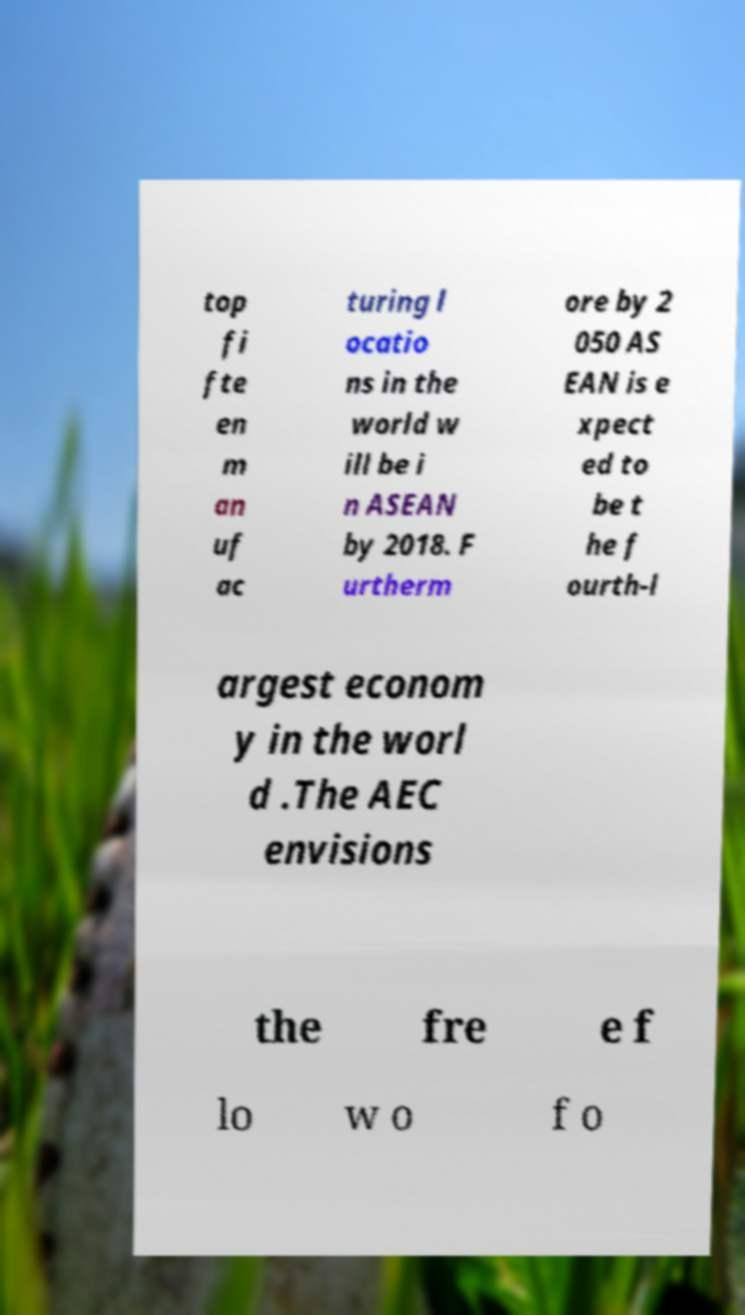Can you accurately transcribe the text from the provided image for me? top fi fte en m an uf ac turing l ocatio ns in the world w ill be i n ASEAN by 2018. F urtherm ore by 2 050 AS EAN is e xpect ed to be t he f ourth-l argest econom y in the worl d .The AEC envisions the fre e f lo w o f o 